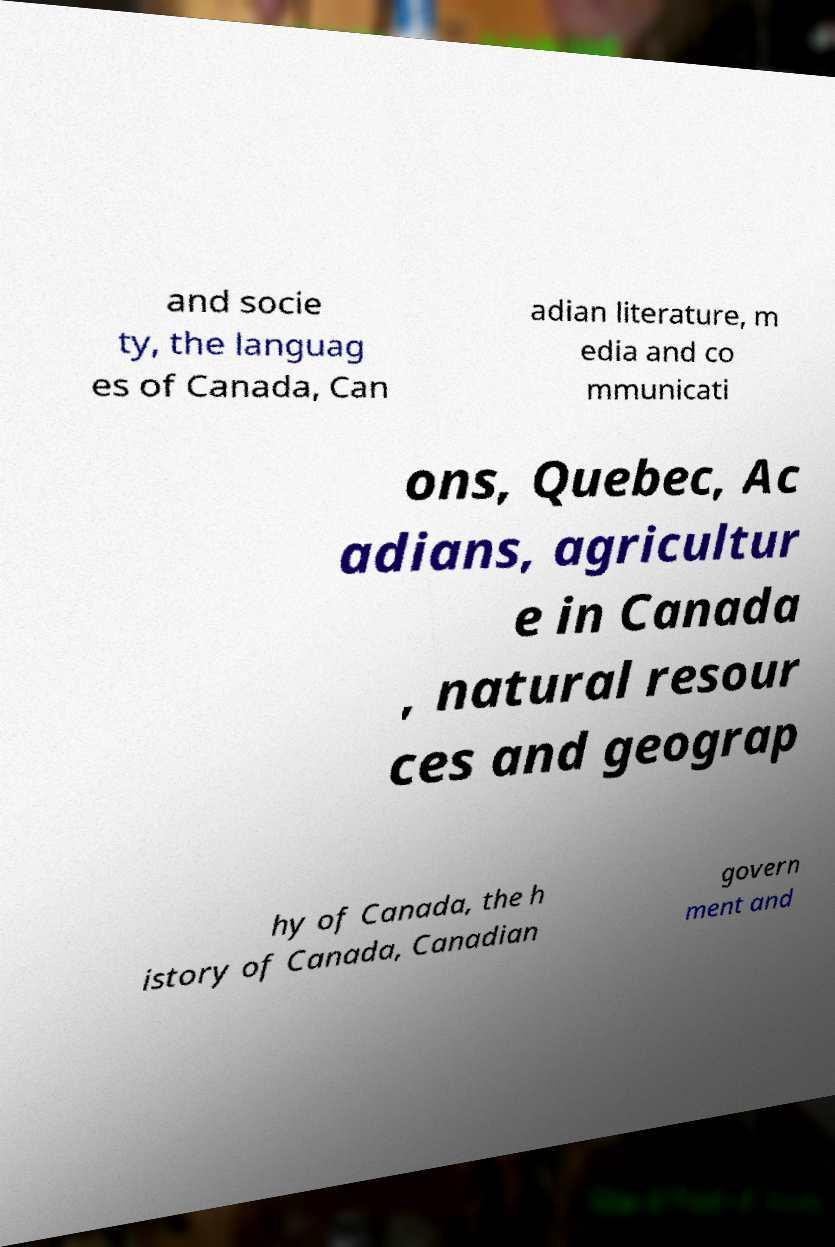Could you extract and type out the text from this image? and socie ty, the languag es of Canada, Can adian literature, m edia and co mmunicati ons, Quebec, Ac adians, agricultur e in Canada , natural resour ces and geograp hy of Canada, the h istory of Canada, Canadian govern ment and 